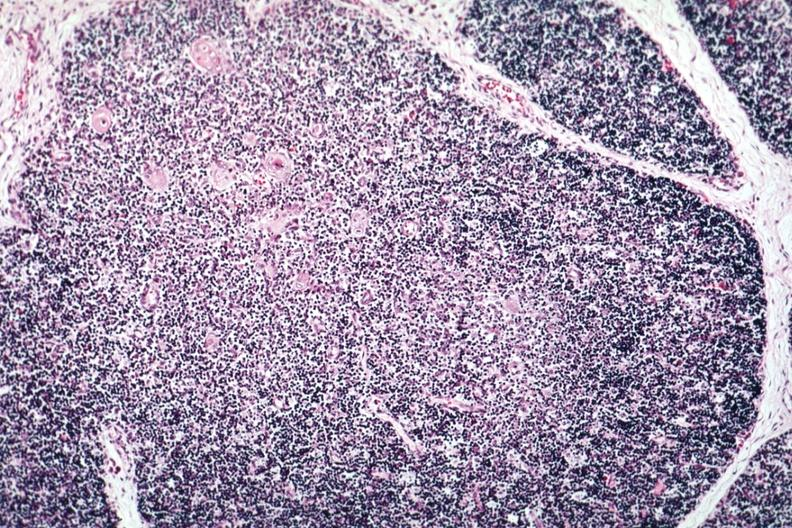s thymus present?
Answer the question using a single word or phrase. Yes 